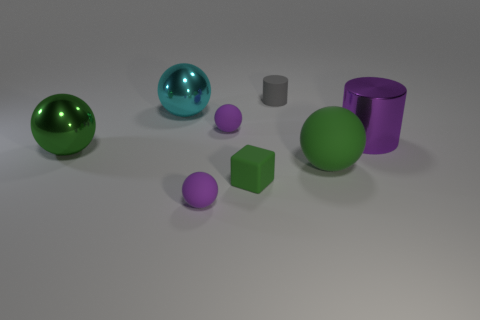Subtract all large green metal balls. How many balls are left? 4 Subtract all cyan balls. How many balls are left? 4 Subtract 2 spheres. How many spheres are left? 3 Subtract all yellow spheres. Subtract all purple cylinders. How many spheres are left? 5 Add 2 large balls. How many objects exist? 10 Subtract all balls. How many objects are left? 3 Subtract all tiny gray things. Subtract all small green rubber blocks. How many objects are left? 6 Add 1 big shiny spheres. How many big shiny spheres are left? 3 Add 6 large cyan balls. How many large cyan balls exist? 7 Subtract 1 cyan spheres. How many objects are left? 7 